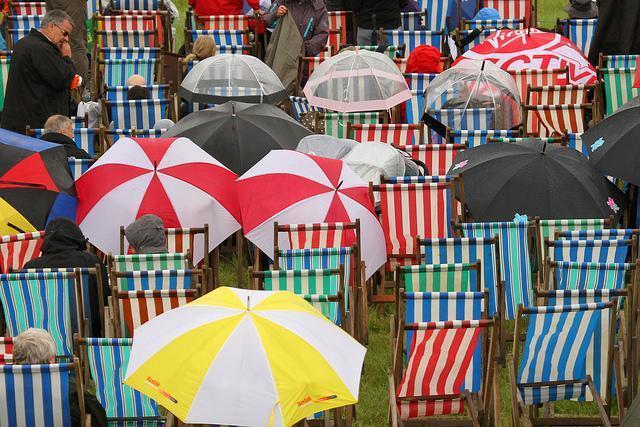How many people are in the photo?
Give a very brief answer. 2. How many umbrellas can you see?
Give a very brief answer. 12. How many chairs can be seen?
Give a very brief answer. 13. 